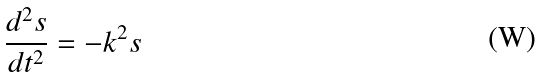<formula> <loc_0><loc_0><loc_500><loc_500>\frac { d ^ { 2 } s } { d t ^ { 2 } } = - k ^ { 2 } s</formula> 